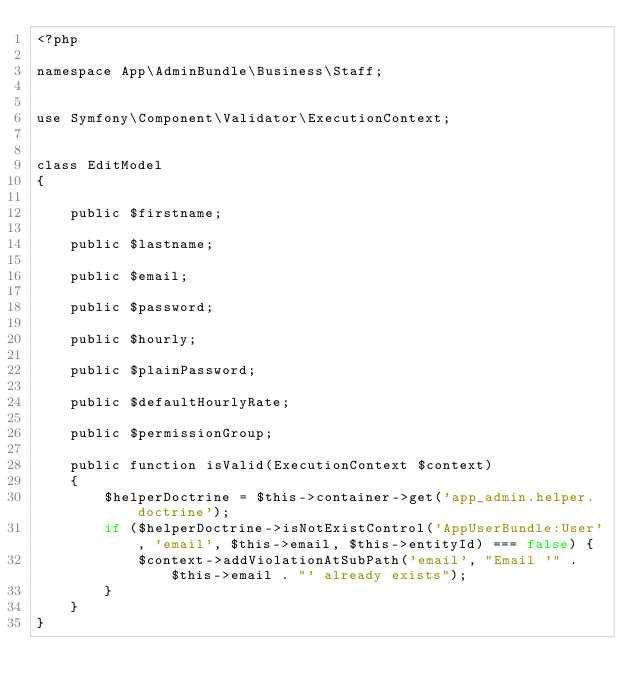Convert code to text. <code><loc_0><loc_0><loc_500><loc_500><_PHP_><?phpnamespace App\AdminBundle\Business\Staff;use Symfony\Component\Validator\ExecutionContext;class EditModel{    public $firstname;    public $lastname;    public $email;    public $password;    public $hourly;    public $plainPassword;    public $defaultHourlyRate;    public $permissionGroup;    public function isValid(ExecutionContext $context)    {        $helperDoctrine = $this->container->get('app_admin.helper.doctrine');        if ($helperDoctrine->isNotExistControl('AppUserBundle:User', 'email', $this->email, $this->entityId) === false) {            $context->addViolationAtSubPath('email', "Email '" . $this->email . "' already exists");        }    }}</code> 